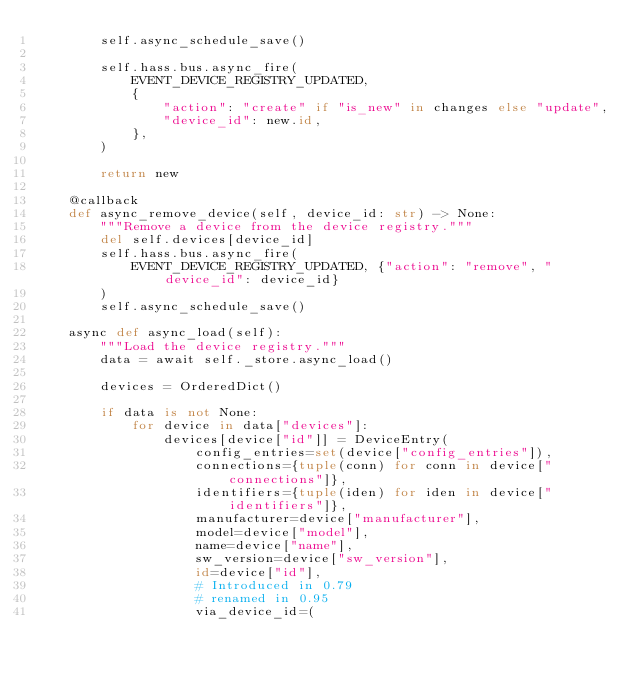<code> <loc_0><loc_0><loc_500><loc_500><_Python_>        self.async_schedule_save()

        self.hass.bus.async_fire(
            EVENT_DEVICE_REGISTRY_UPDATED,
            {
                "action": "create" if "is_new" in changes else "update",
                "device_id": new.id,
            },
        )

        return new

    @callback
    def async_remove_device(self, device_id: str) -> None:
        """Remove a device from the device registry."""
        del self.devices[device_id]
        self.hass.bus.async_fire(
            EVENT_DEVICE_REGISTRY_UPDATED, {"action": "remove", "device_id": device_id}
        )
        self.async_schedule_save()

    async def async_load(self):
        """Load the device registry."""
        data = await self._store.async_load()

        devices = OrderedDict()

        if data is not None:
            for device in data["devices"]:
                devices[device["id"]] = DeviceEntry(
                    config_entries=set(device["config_entries"]),
                    connections={tuple(conn) for conn in device["connections"]},
                    identifiers={tuple(iden) for iden in device["identifiers"]},
                    manufacturer=device["manufacturer"],
                    model=device["model"],
                    name=device["name"],
                    sw_version=device["sw_version"],
                    id=device["id"],
                    # Introduced in 0.79
                    # renamed in 0.95
                    via_device_id=(</code> 